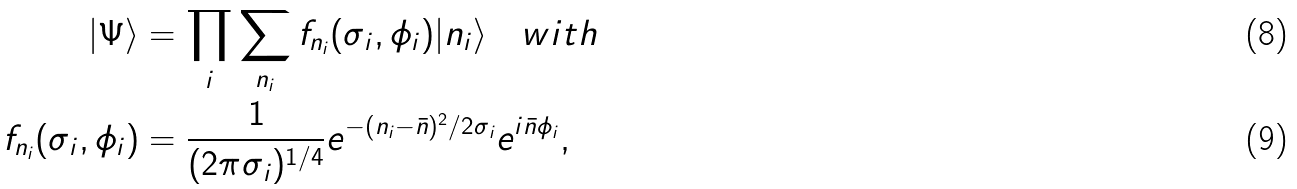<formula> <loc_0><loc_0><loc_500><loc_500>| \Psi \rangle & = \prod _ { i } \sum _ { n _ { i } } f _ { n _ { i } } ( \sigma _ { i } , \phi _ { i } ) | n _ { i } \rangle \quad w i t h \\ f _ { n _ { i } } ( \sigma _ { i } , \phi _ { i } ) & = \frac { 1 } { ( 2 \pi \sigma _ { i } ) ^ { 1 / 4 } } e ^ { - ( n _ { i } - \bar { n } ) ^ { 2 } / 2 \sigma _ { i } } e ^ { i \bar { n } \phi _ { i } } ,</formula> 